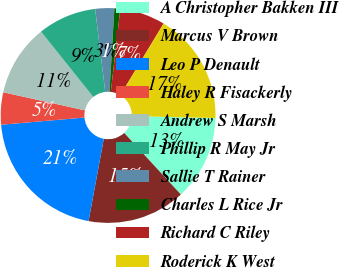Convert chart to OTSL. <chart><loc_0><loc_0><loc_500><loc_500><pie_chart><fcel>A Christopher Bakken III<fcel>Marcus V Brown<fcel>Leo P Denault<fcel>Haley R Fisackerly<fcel>Andrew S Marsh<fcel>Phillip R May Jr<fcel>Sallie T Rainer<fcel>Charles L Rice Jr<fcel>Richard C Riley<fcel>Roderick K West<nl><fcel>12.78%<fcel>14.76%<fcel>20.71%<fcel>4.85%<fcel>10.79%<fcel>8.81%<fcel>2.86%<fcel>0.88%<fcel>6.83%<fcel>16.74%<nl></chart> 